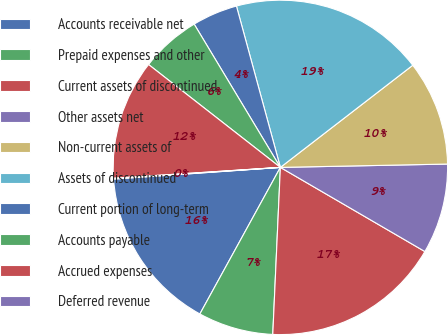<chart> <loc_0><loc_0><loc_500><loc_500><pie_chart><fcel>Accounts receivable net<fcel>Prepaid expenses and other<fcel>Current assets of discontinued<fcel>Other assets net<fcel>Non-current assets of<fcel>Assets of discontinued<fcel>Current portion of long-term<fcel>Accounts payable<fcel>Accrued expenses<fcel>Deferred revenue<nl><fcel>15.89%<fcel>7.27%<fcel>17.33%<fcel>8.71%<fcel>10.14%<fcel>18.77%<fcel>4.39%<fcel>5.83%<fcel>11.58%<fcel>0.08%<nl></chart> 